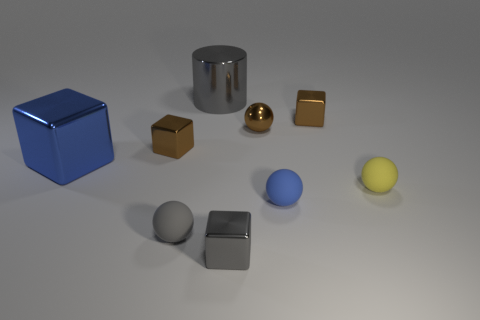How many big blue shiny objects are the same shape as the small gray metallic object?
Provide a succinct answer. 1. What is the shape of the small yellow object?
Make the answer very short. Sphere. Is the number of small blue things less than the number of large red cylinders?
Your answer should be compact. No. What is the material of the gray object that is the same shape as the yellow thing?
Your answer should be compact. Rubber. Is the number of large gray metal objects greater than the number of cyan cylinders?
Your response must be concise. Yes. What number of other objects are there of the same color as the tiny metallic sphere?
Provide a succinct answer. 2. Does the blue block have the same material as the blue object that is in front of the big metal block?
Offer a terse response. No. What number of small matte spheres are right of the ball behind the tiny brown object that is left of the gray ball?
Your answer should be very brief. 2. Is the number of tiny brown things on the right side of the brown metallic ball less than the number of brown shiny spheres that are left of the tiny blue matte thing?
Give a very brief answer. No. What number of other things are there of the same material as the small yellow object
Offer a very short reply. 2. 